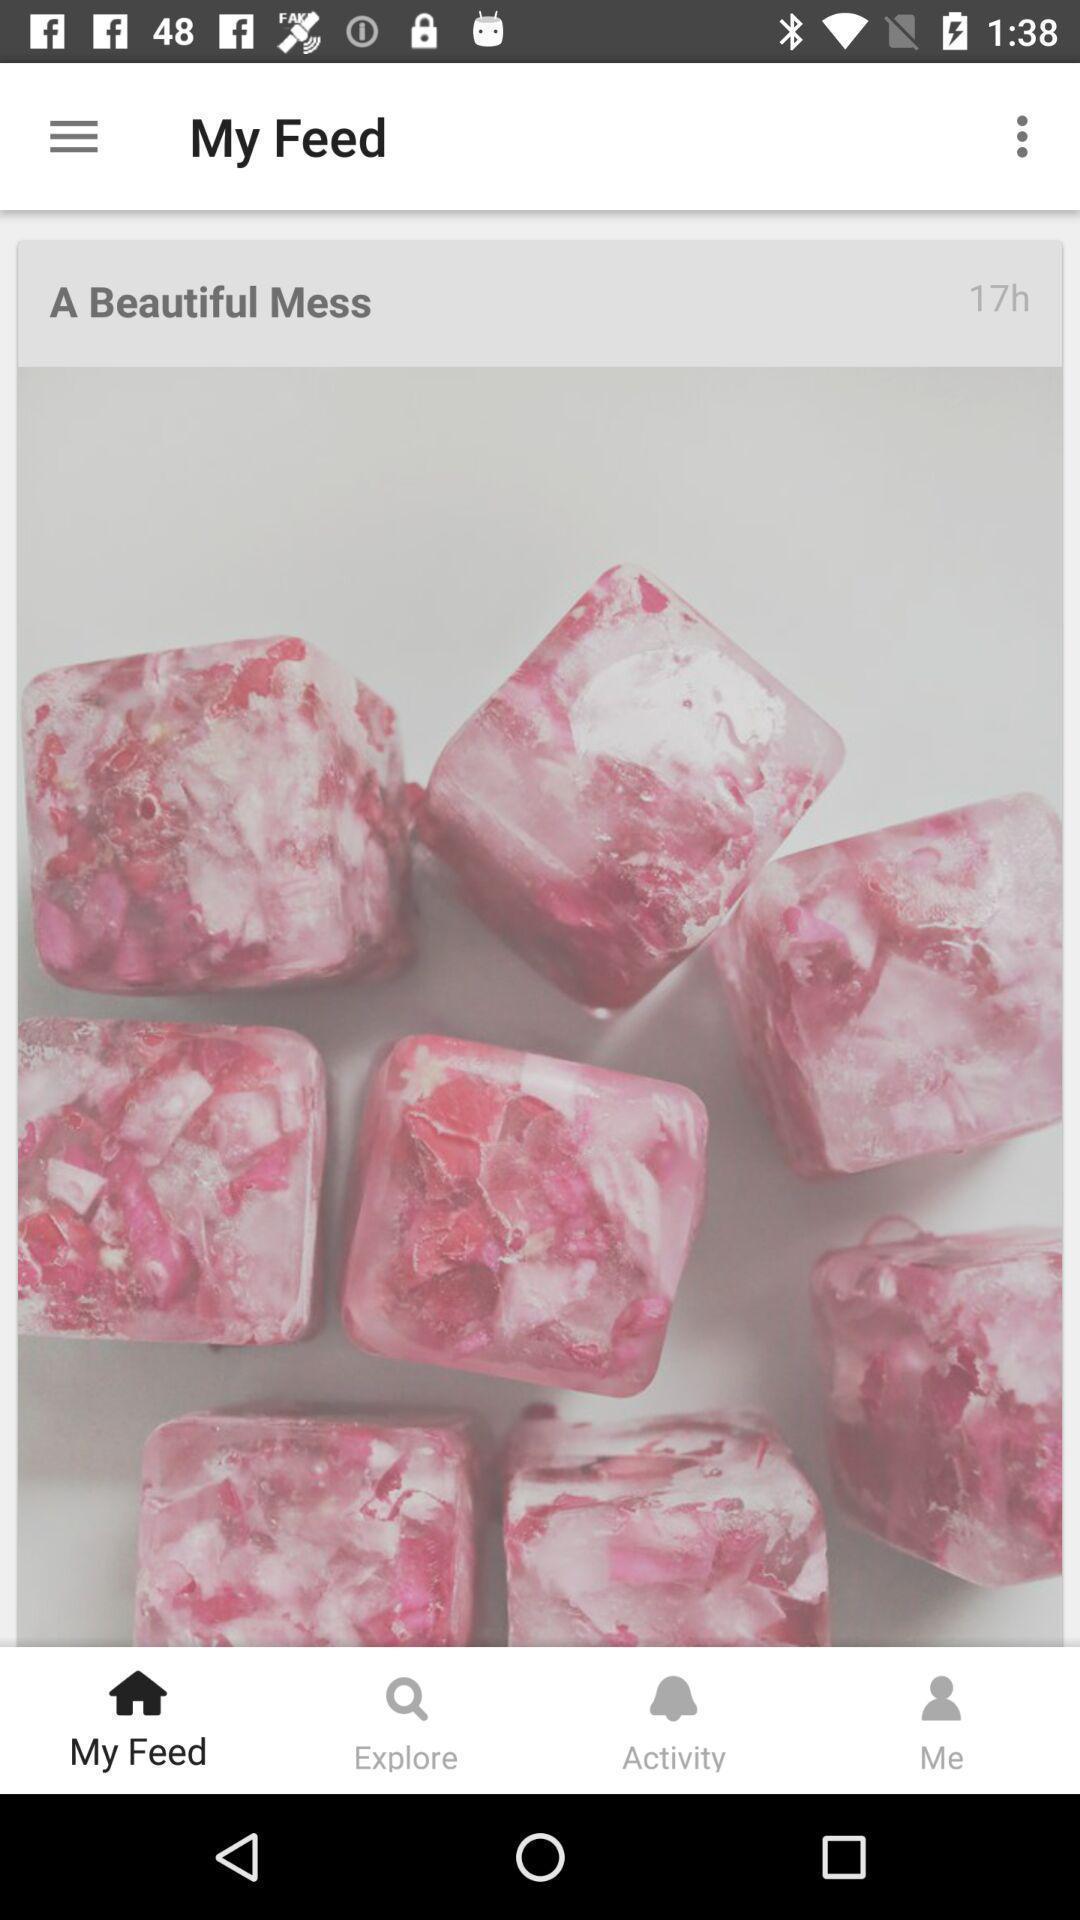Explain what's happening in this screen capture. Screen showing an image in a social app. 